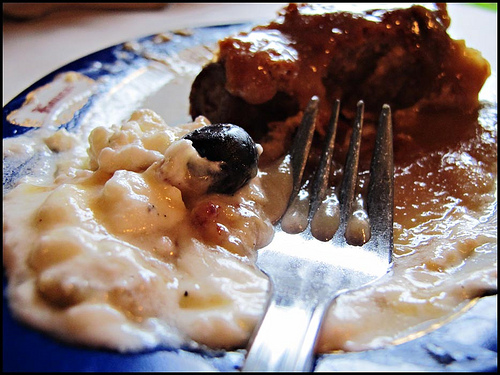<image>
Is the fork on the plate? Yes. Looking at the image, I can see the fork is positioned on top of the plate, with the plate providing support. 